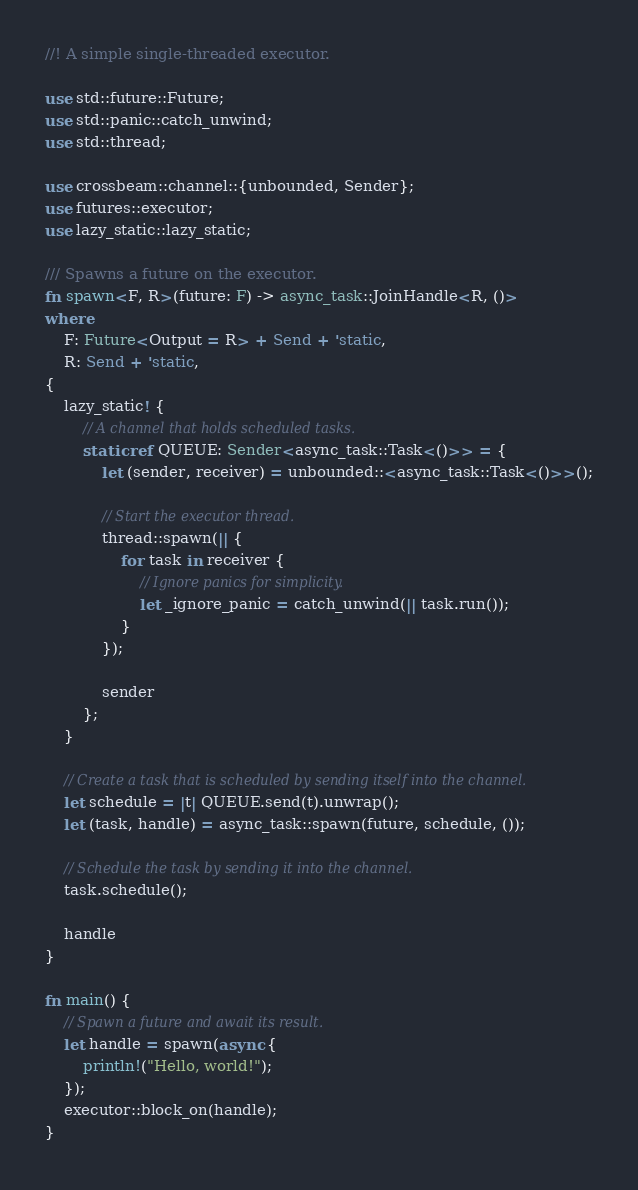<code> <loc_0><loc_0><loc_500><loc_500><_Rust_>//! A simple single-threaded executor.

use std::future::Future;
use std::panic::catch_unwind;
use std::thread;

use crossbeam::channel::{unbounded, Sender};
use futures::executor;
use lazy_static::lazy_static;

/// Spawns a future on the executor.
fn spawn<F, R>(future: F) -> async_task::JoinHandle<R, ()>
where
    F: Future<Output = R> + Send + 'static,
    R: Send + 'static,
{
    lazy_static! {
        // A channel that holds scheduled tasks.
        static ref QUEUE: Sender<async_task::Task<()>> = {
            let (sender, receiver) = unbounded::<async_task::Task<()>>();

            // Start the executor thread.
            thread::spawn(|| {
                for task in receiver {
                    // Ignore panics for simplicity.
                    let _ignore_panic = catch_unwind(|| task.run());
                }
            });

            sender
        };
    }

    // Create a task that is scheduled by sending itself into the channel.
    let schedule = |t| QUEUE.send(t).unwrap();
    let (task, handle) = async_task::spawn(future, schedule, ());

    // Schedule the task by sending it into the channel.
    task.schedule();

    handle
}

fn main() {
    // Spawn a future and await its result.
    let handle = spawn(async {
        println!("Hello, world!");
    });
    executor::block_on(handle);
}
</code> 